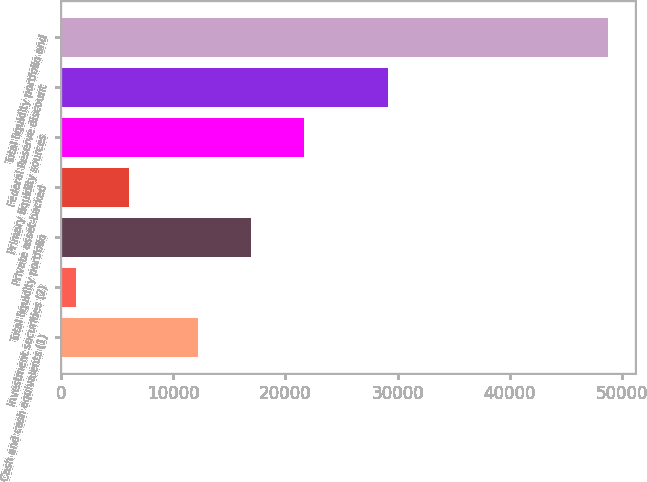<chart> <loc_0><loc_0><loc_500><loc_500><bar_chart><fcel>Cash and cash equivalents (1)<fcel>Investment securities (2)<fcel>Total liquidity portfolio<fcel>Private asset-backed<fcel>Primary liquidity sources<fcel>Federal Reserve discount<fcel>Total liquidity portfolio and<nl><fcel>12213<fcel>1347<fcel>16949.6<fcel>6083.6<fcel>21686.2<fcel>29153<fcel>48713<nl></chart> 